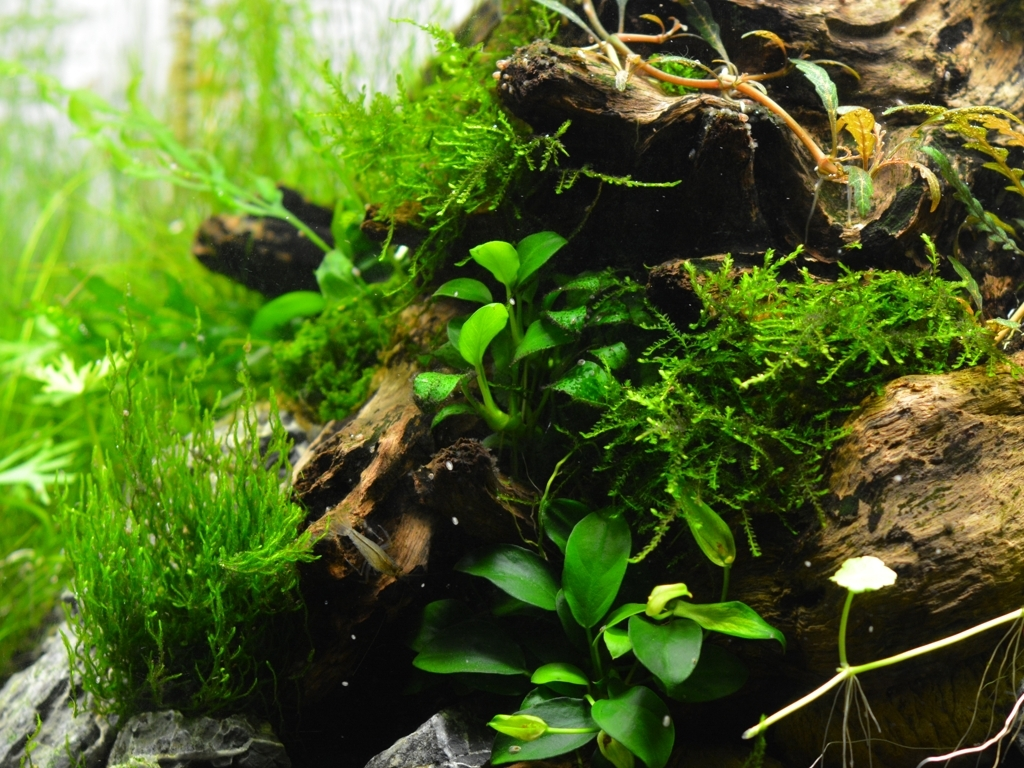Can you tell me more about how the branches are used in this setup? Certainly! The branches, often referred to as driftwood in aquascaping, serve multiple purposes. They create a natural aesthetic, resembling the underwater environment of a river or stream, and they also provide structure for the plants to attach to and grow upon. Over time, as the wood becomes waterlogged and develops biofilm, it can also become a source of food and shelter for any aquatic life in the ecosystem. 